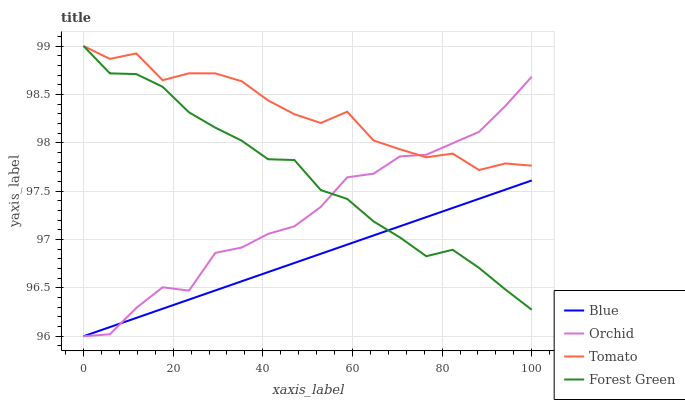Does Blue have the minimum area under the curve?
Answer yes or no. Yes. Does Tomato have the maximum area under the curve?
Answer yes or no. Yes. Does Forest Green have the minimum area under the curve?
Answer yes or no. No. Does Forest Green have the maximum area under the curve?
Answer yes or no. No. Is Blue the smoothest?
Answer yes or no. Yes. Is Tomato the roughest?
Answer yes or no. Yes. Is Forest Green the smoothest?
Answer yes or no. No. Is Forest Green the roughest?
Answer yes or no. No. Does Blue have the lowest value?
Answer yes or no. Yes. Does Forest Green have the lowest value?
Answer yes or no. No. Does Forest Green have the highest value?
Answer yes or no. Yes. Does Orchid have the highest value?
Answer yes or no. No. Is Blue less than Tomato?
Answer yes or no. Yes. Is Tomato greater than Blue?
Answer yes or no. Yes. Does Tomato intersect Orchid?
Answer yes or no. Yes. Is Tomato less than Orchid?
Answer yes or no. No. Is Tomato greater than Orchid?
Answer yes or no. No. Does Blue intersect Tomato?
Answer yes or no. No. 